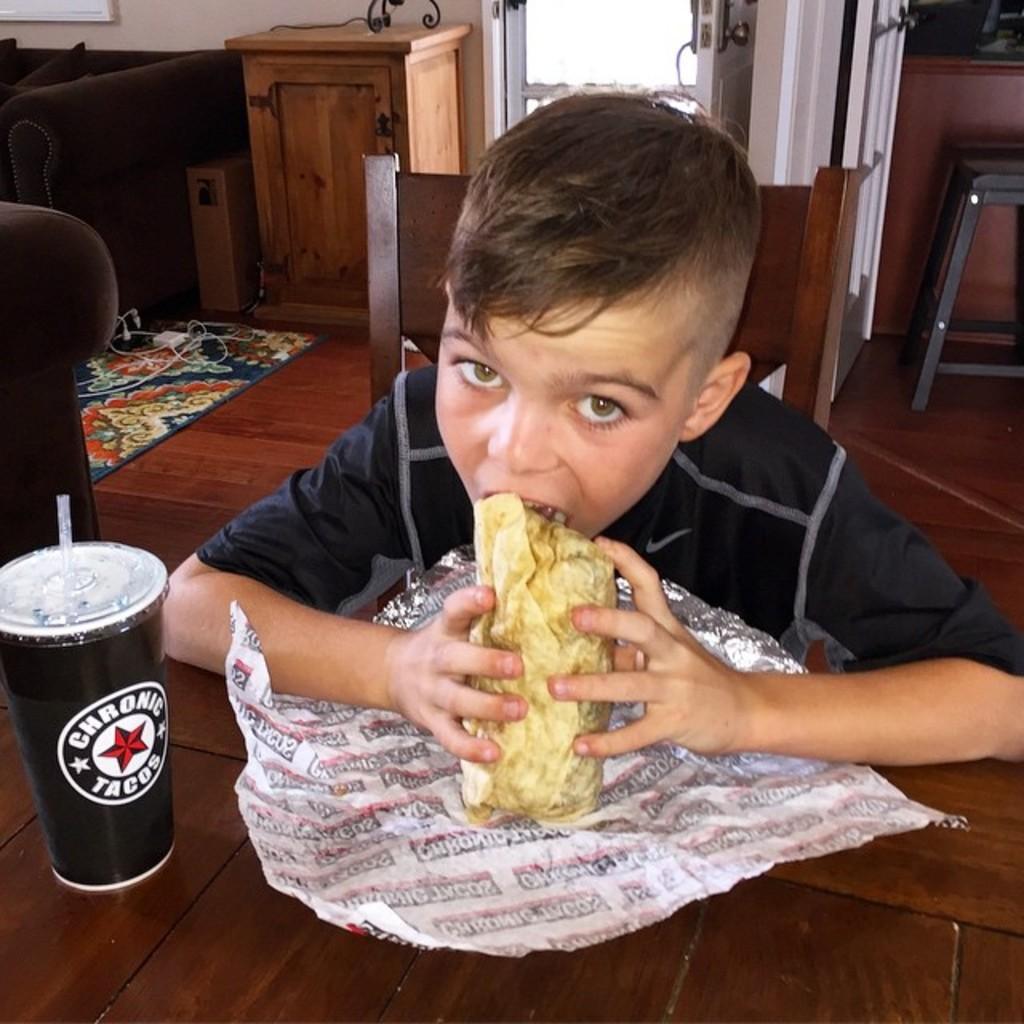In one or two sentences, can you explain what this image depicts? In the center of the image we can see a boy sitting at the table and eating food. On the table we can see glass. In the background we can see cupboard, door, stool, sofa and wall. 